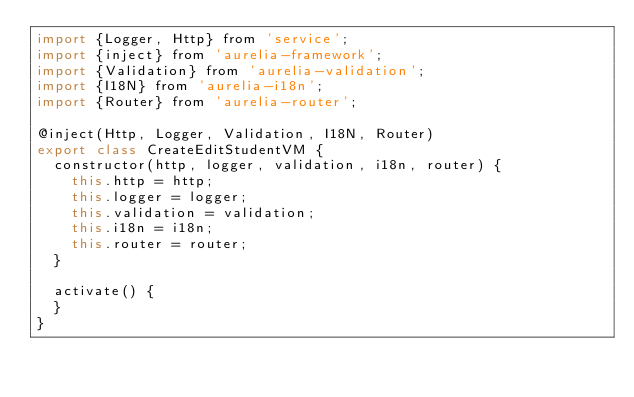<code> <loc_0><loc_0><loc_500><loc_500><_JavaScript_>import {Logger, Http} from 'service';
import {inject} from 'aurelia-framework';
import {Validation} from 'aurelia-validation';
import {I18N} from 'aurelia-i18n';
import {Router} from 'aurelia-router';

@inject(Http, Logger, Validation, I18N, Router)
export class CreateEditStudentVM {
  constructor(http, logger, validation, i18n, router) {
    this.http = http;
    this.logger = logger;
    this.validation = validation;
    this.i18n = i18n;
    this.router = router;
  }

  activate() {
  }
}

</code> 